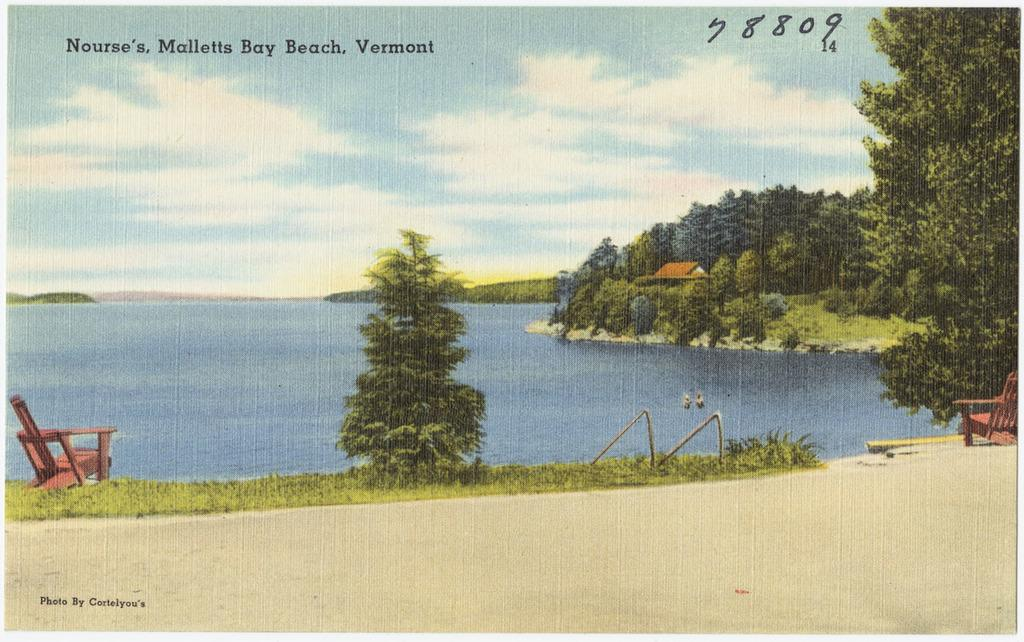What type of vegetation can be seen in the image? There are trees in the image. What color are the trees? The trees are green. What structure is visible in the background of the image? There is a house in the background of the image. What color is the house? The house is brown. What natural element is visible in the image? There is water visible in the image. What color is the water? The water is blue. What part of the sky is visible in the image? The sky is visible in the image. What colors are present in the sky? The sky is blue and white. Where is the pen located in the image? There is no pen present in the image. Can you see a swing in the image? There is no swing present in the image. 